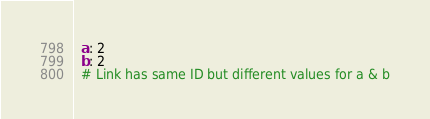<code> <loc_0><loc_0><loc_500><loc_500><_YAML_>  a: 2
  b: 2
  # Link has same ID but different values for a & b
</code> 